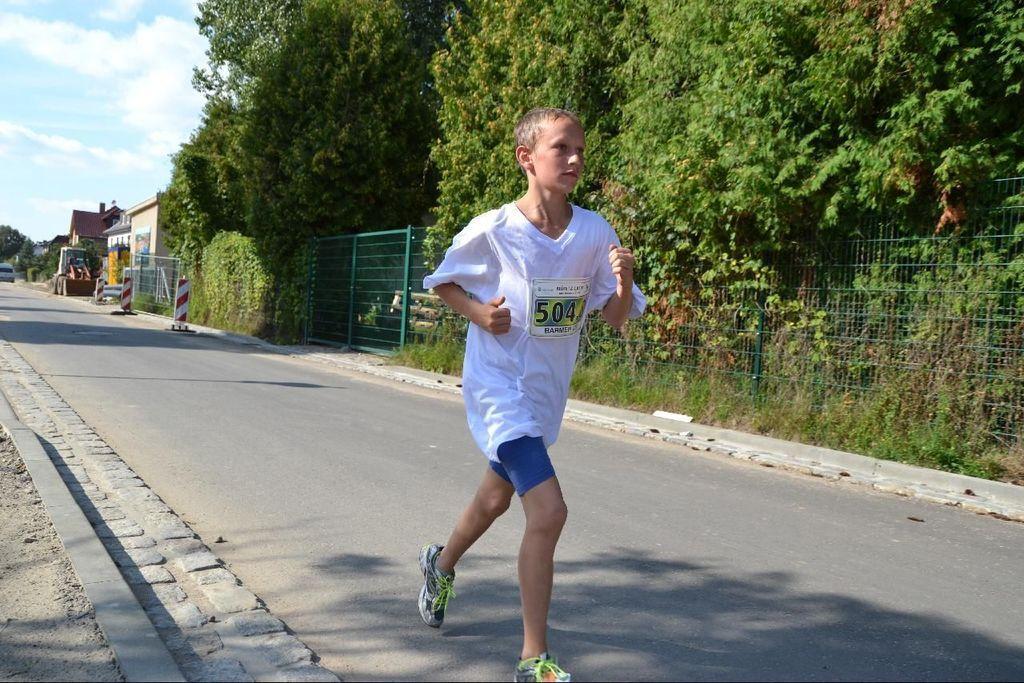How would you summarize this image in a sentence or two? In this image, we can see a person is running on the road. Background we can see trees, fence and plants. On the left side of the image, we can see the walkway, vehicle, houses, trees and cloudy sky. 